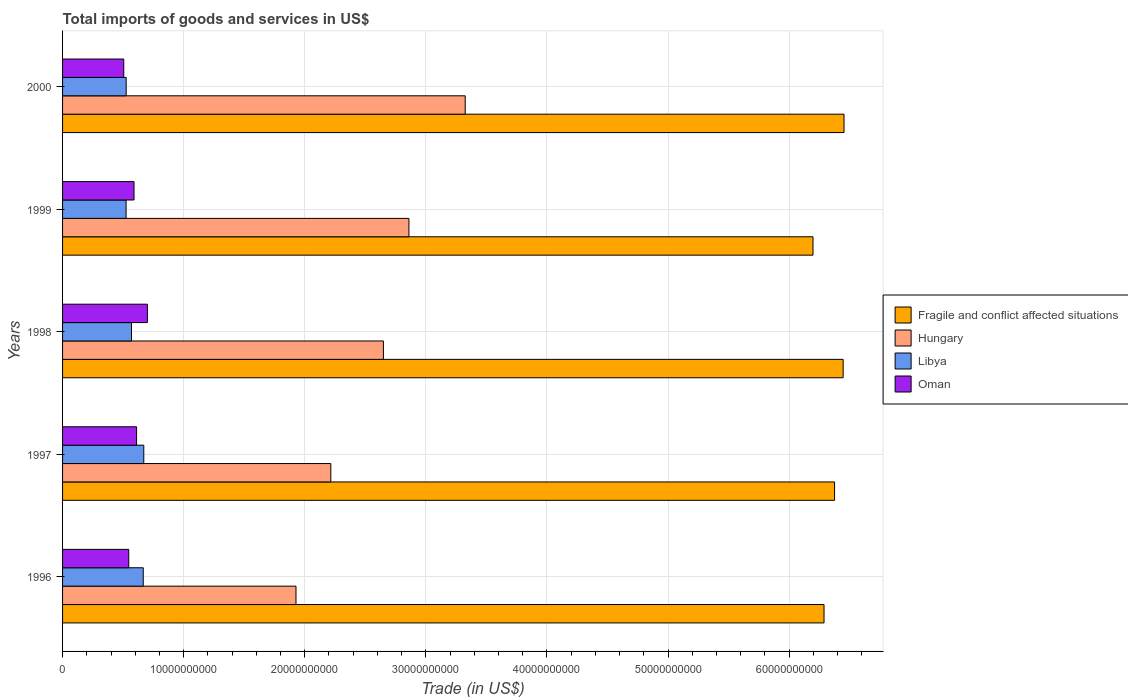Are the number of bars per tick equal to the number of legend labels?
Ensure brevity in your answer.  Yes. How many bars are there on the 4th tick from the top?
Ensure brevity in your answer.  4. How many bars are there on the 2nd tick from the bottom?
Your answer should be very brief. 4. What is the label of the 2nd group of bars from the top?
Make the answer very short. 1999. What is the total imports of goods and services in Hungary in 1997?
Your response must be concise. 2.22e+1. Across all years, what is the maximum total imports of goods and services in Libya?
Offer a terse response. 6.71e+09. Across all years, what is the minimum total imports of goods and services in Oman?
Give a very brief answer. 5.05e+09. In which year was the total imports of goods and services in Oman maximum?
Provide a succinct answer. 1998. What is the total total imports of goods and services in Fragile and conflict affected situations in the graph?
Make the answer very short. 3.18e+11. What is the difference between the total imports of goods and services in Hungary in 1996 and that in 2000?
Give a very brief answer. -1.40e+1. What is the difference between the total imports of goods and services in Libya in 2000 and the total imports of goods and services in Fragile and conflict affected situations in 1998?
Offer a very short reply. -5.92e+1. What is the average total imports of goods and services in Libya per year?
Ensure brevity in your answer.  5.91e+09. In the year 1996, what is the difference between the total imports of goods and services in Libya and total imports of goods and services in Fragile and conflict affected situations?
Provide a short and direct response. -5.62e+1. What is the ratio of the total imports of goods and services in Libya in 1996 to that in 1999?
Ensure brevity in your answer.  1.27. Is the total imports of goods and services in Libya in 1998 less than that in 1999?
Provide a succinct answer. No. Is the difference between the total imports of goods and services in Libya in 1996 and 2000 greater than the difference between the total imports of goods and services in Fragile and conflict affected situations in 1996 and 2000?
Make the answer very short. Yes. What is the difference between the highest and the second highest total imports of goods and services in Hungary?
Provide a succinct answer. 4.65e+09. What is the difference between the highest and the lowest total imports of goods and services in Hungary?
Your answer should be compact. 1.40e+1. Is the sum of the total imports of goods and services in Hungary in 1999 and 2000 greater than the maximum total imports of goods and services in Fragile and conflict affected situations across all years?
Your answer should be compact. No. Is it the case that in every year, the sum of the total imports of goods and services in Libya and total imports of goods and services in Oman is greater than the sum of total imports of goods and services in Fragile and conflict affected situations and total imports of goods and services in Hungary?
Give a very brief answer. No. What does the 3rd bar from the top in 1997 represents?
Offer a very short reply. Hungary. What does the 1st bar from the bottom in 1998 represents?
Make the answer very short. Fragile and conflict affected situations. How many bars are there?
Ensure brevity in your answer.  20. What is the difference between two consecutive major ticks on the X-axis?
Provide a short and direct response. 1.00e+1. Are the values on the major ticks of X-axis written in scientific E-notation?
Your response must be concise. No. Does the graph contain any zero values?
Your answer should be very brief. No. Does the graph contain grids?
Give a very brief answer. Yes. Where does the legend appear in the graph?
Offer a terse response. Center right. How many legend labels are there?
Keep it short and to the point. 4. What is the title of the graph?
Give a very brief answer. Total imports of goods and services in US$. What is the label or title of the X-axis?
Provide a short and direct response. Trade (in US$). What is the label or title of the Y-axis?
Make the answer very short. Years. What is the Trade (in US$) of Fragile and conflict affected situations in 1996?
Offer a very short reply. 6.29e+1. What is the Trade (in US$) in Hungary in 1996?
Ensure brevity in your answer.  1.93e+1. What is the Trade (in US$) of Libya in 1996?
Keep it short and to the point. 6.66e+09. What is the Trade (in US$) in Oman in 1996?
Your answer should be compact. 5.46e+09. What is the Trade (in US$) of Fragile and conflict affected situations in 1997?
Ensure brevity in your answer.  6.37e+1. What is the Trade (in US$) of Hungary in 1997?
Provide a short and direct response. 2.22e+1. What is the Trade (in US$) in Libya in 1997?
Your response must be concise. 6.71e+09. What is the Trade (in US$) in Oman in 1997?
Offer a terse response. 6.11e+09. What is the Trade (in US$) in Fragile and conflict affected situations in 1998?
Your answer should be very brief. 6.45e+1. What is the Trade (in US$) of Hungary in 1998?
Offer a very short reply. 2.65e+1. What is the Trade (in US$) in Libya in 1998?
Offer a terse response. 5.69e+09. What is the Trade (in US$) of Oman in 1998?
Your answer should be compact. 7.00e+09. What is the Trade (in US$) of Fragile and conflict affected situations in 1999?
Your answer should be compact. 6.20e+1. What is the Trade (in US$) in Hungary in 1999?
Make the answer very short. 2.86e+1. What is the Trade (in US$) in Libya in 1999?
Ensure brevity in your answer.  5.25e+09. What is the Trade (in US$) in Oman in 1999?
Offer a terse response. 5.90e+09. What is the Trade (in US$) of Fragile and conflict affected situations in 2000?
Provide a short and direct response. 6.45e+1. What is the Trade (in US$) of Hungary in 2000?
Your response must be concise. 3.32e+1. What is the Trade (in US$) of Libya in 2000?
Offer a very short reply. 5.25e+09. What is the Trade (in US$) in Oman in 2000?
Your response must be concise. 5.05e+09. Across all years, what is the maximum Trade (in US$) of Fragile and conflict affected situations?
Your answer should be compact. 6.45e+1. Across all years, what is the maximum Trade (in US$) in Hungary?
Make the answer very short. 3.32e+1. Across all years, what is the maximum Trade (in US$) in Libya?
Provide a short and direct response. 6.71e+09. Across all years, what is the maximum Trade (in US$) of Oman?
Your answer should be very brief. 7.00e+09. Across all years, what is the minimum Trade (in US$) of Fragile and conflict affected situations?
Provide a short and direct response. 6.20e+1. Across all years, what is the minimum Trade (in US$) of Hungary?
Ensure brevity in your answer.  1.93e+1. Across all years, what is the minimum Trade (in US$) of Libya?
Offer a terse response. 5.25e+09. Across all years, what is the minimum Trade (in US$) in Oman?
Give a very brief answer. 5.05e+09. What is the total Trade (in US$) in Fragile and conflict affected situations in the graph?
Your response must be concise. 3.18e+11. What is the total Trade (in US$) of Hungary in the graph?
Your answer should be compact. 1.30e+11. What is the total Trade (in US$) of Libya in the graph?
Offer a very short reply. 2.96e+1. What is the total Trade (in US$) in Oman in the graph?
Your response must be concise. 2.95e+1. What is the difference between the Trade (in US$) of Fragile and conflict affected situations in 1996 and that in 1997?
Your response must be concise. -8.70e+08. What is the difference between the Trade (in US$) in Hungary in 1996 and that in 1997?
Ensure brevity in your answer.  -2.88e+09. What is the difference between the Trade (in US$) in Libya in 1996 and that in 1997?
Offer a very short reply. -4.44e+07. What is the difference between the Trade (in US$) of Oman in 1996 and that in 1997?
Offer a very short reply. -6.48e+08. What is the difference between the Trade (in US$) of Fragile and conflict affected situations in 1996 and that in 1998?
Keep it short and to the point. -1.58e+09. What is the difference between the Trade (in US$) in Hungary in 1996 and that in 1998?
Offer a very short reply. -7.22e+09. What is the difference between the Trade (in US$) in Libya in 1996 and that in 1998?
Make the answer very short. 9.71e+08. What is the difference between the Trade (in US$) in Oman in 1996 and that in 1998?
Offer a terse response. -1.54e+09. What is the difference between the Trade (in US$) of Fragile and conflict affected situations in 1996 and that in 1999?
Ensure brevity in your answer.  9.10e+08. What is the difference between the Trade (in US$) of Hungary in 1996 and that in 1999?
Offer a terse response. -9.33e+09. What is the difference between the Trade (in US$) of Libya in 1996 and that in 1999?
Give a very brief answer. 1.42e+09. What is the difference between the Trade (in US$) of Oman in 1996 and that in 1999?
Give a very brief answer. -4.37e+08. What is the difference between the Trade (in US$) in Fragile and conflict affected situations in 1996 and that in 2000?
Ensure brevity in your answer.  -1.65e+09. What is the difference between the Trade (in US$) in Hungary in 1996 and that in 2000?
Your answer should be compact. -1.40e+1. What is the difference between the Trade (in US$) of Libya in 1996 and that in 2000?
Give a very brief answer. 1.41e+09. What is the difference between the Trade (in US$) in Oman in 1996 and that in 2000?
Your answer should be compact. 4.11e+08. What is the difference between the Trade (in US$) in Fragile and conflict affected situations in 1997 and that in 1998?
Your response must be concise. -7.10e+08. What is the difference between the Trade (in US$) in Hungary in 1997 and that in 1998?
Give a very brief answer. -4.34e+09. What is the difference between the Trade (in US$) in Libya in 1997 and that in 1998?
Keep it short and to the point. 1.02e+09. What is the difference between the Trade (in US$) of Oman in 1997 and that in 1998?
Your answer should be very brief. -8.92e+08. What is the difference between the Trade (in US$) of Fragile and conflict affected situations in 1997 and that in 1999?
Offer a terse response. 1.78e+09. What is the difference between the Trade (in US$) of Hungary in 1997 and that in 1999?
Make the answer very short. -6.45e+09. What is the difference between the Trade (in US$) of Libya in 1997 and that in 1999?
Provide a succinct answer. 1.46e+09. What is the difference between the Trade (in US$) in Oman in 1997 and that in 1999?
Provide a succinct answer. 2.11e+08. What is the difference between the Trade (in US$) in Fragile and conflict affected situations in 1997 and that in 2000?
Your answer should be very brief. -7.82e+08. What is the difference between the Trade (in US$) in Hungary in 1997 and that in 2000?
Give a very brief answer. -1.11e+1. What is the difference between the Trade (in US$) in Libya in 1997 and that in 2000?
Your answer should be very brief. 1.45e+09. What is the difference between the Trade (in US$) in Oman in 1997 and that in 2000?
Give a very brief answer. 1.06e+09. What is the difference between the Trade (in US$) of Fragile and conflict affected situations in 1998 and that in 1999?
Your answer should be compact. 2.49e+09. What is the difference between the Trade (in US$) of Hungary in 1998 and that in 1999?
Provide a succinct answer. -2.11e+09. What is the difference between the Trade (in US$) of Libya in 1998 and that in 1999?
Provide a succinct answer. 4.45e+08. What is the difference between the Trade (in US$) of Oman in 1998 and that in 1999?
Offer a very short reply. 1.10e+09. What is the difference between the Trade (in US$) in Fragile and conflict affected situations in 1998 and that in 2000?
Provide a short and direct response. -7.17e+07. What is the difference between the Trade (in US$) of Hungary in 1998 and that in 2000?
Offer a very short reply. -6.76e+09. What is the difference between the Trade (in US$) in Libya in 1998 and that in 2000?
Provide a short and direct response. 4.39e+08. What is the difference between the Trade (in US$) of Oman in 1998 and that in 2000?
Provide a short and direct response. 1.95e+09. What is the difference between the Trade (in US$) of Fragile and conflict affected situations in 1999 and that in 2000?
Your answer should be compact. -2.56e+09. What is the difference between the Trade (in US$) in Hungary in 1999 and that in 2000?
Ensure brevity in your answer.  -4.65e+09. What is the difference between the Trade (in US$) of Libya in 1999 and that in 2000?
Give a very brief answer. -6.06e+06. What is the difference between the Trade (in US$) of Oman in 1999 and that in 2000?
Keep it short and to the point. 8.48e+08. What is the difference between the Trade (in US$) in Fragile and conflict affected situations in 1996 and the Trade (in US$) in Hungary in 1997?
Provide a succinct answer. 4.07e+1. What is the difference between the Trade (in US$) in Fragile and conflict affected situations in 1996 and the Trade (in US$) in Libya in 1997?
Make the answer very short. 5.62e+1. What is the difference between the Trade (in US$) of Fragile and conflict affected situations in 1996 and the Trade (in US$) of Oman in 1997?
Your answer should be compact. 5.68e+1. What is the difference between the Trade (in US$) of Hungary in 1996 and the Trade (in US$) of Libya in 1997?
Your response must be concise. 1.26e+1. What is the difference between the Trade (in US$) in Hungary in 1996 and the Trade (in US$) in Oman in 1997?
Make the answer very short. 1.32e+1. What is the difference between the Trade (in US$) of Libya in 1996 and the Trade (in US$) of Oman in 1997?
Provide a succinct answer. 5.50e+08. What is the difference between the Trade (in US$) in Fragile and conflict affected situations in 1996 and the Trade (in US$) in Hungary in 1998?
Your answer should be very brief. 3.64e+1. What is the difference between the Trade (in US$) of Fragile and conflict affected situations in 1996 and the Trade (in US$) of Libya in 1998?
Provide a short and direct response. 5.72e+1. What is the difference between the Trade (in US$) of Fragile and conflict affected situations in 1996 and the Trade (in US$) of Oman in 1998?
Provide a short and direct response. 5.59e+1. What is the difference between the Trade (in US$) in Hungary in 1996 and the Trade (in US$) in Libya in 1998?
Ensure brevity in your answer.  1.36e+1. What is the difference between the Trade (in US$) in Hungary in 1996 and the Trade (in US$) in Oman in 1998?
Provide a succinct answer. 1.23e+1. What is the difference between the Trade (in US$) in Libya in 1996 and the Trade (in US$) in Oman in 1998?
Give a very brief answer. -3.42e+08. What is the difference between the Trade (in US$) in Fragile and conflict affected situations in 1996 and the Trade (in US$) in Hungary in 1999?
Give a very brief answer. 3.43e+1. What is the difference between the Trade (in US$) of Fragile and conflict affected situations in 1996 and the Trade (in US$) of Libya in 1999?
Your answer should be compact. 5.76e+1. What is the difference between the Trade (in US$) of Fragile and conflict affected situations in 1996 and the Trade (in US$) of Oman in 1999?
Provide a short and direct response. 5.70e+1. What is the difference between the Trade (in US$) in Hungary in 1996 and the Trade (in US$) in Libya in 1999?
Ensure brevity in your answer.  1.40e+1. What is the difference between the Trade (in US$) in Hungary in 1996 and the Trade (in US$) in Oman in 1999?
Provide a short and direct response. 1.34e+1. What is the difference between the Trade (in US$) in Libya in 1996 and the Trade (in US$) in Oman in 1999?
Ensure brevity in your answer.  7.61e+08. What is the difference between the Trade (in US$) of Fragile and conflict affected situations in 1996 and the Trade (in US$) of Hungary in 2000?
Your response must be concise. 2.96e+1. What is the difference between the Trade (in US$) in Fragile and conflict affected situations in 1996 and the Trade (in US$) in Libya in 2000?
Provide a succinct answer. 5.76e+1. What is the difference between the Trade (in US$) in Fragile and conflict affected situations in 1996 and the Trade (in US$) in Oman in 2000?
Offer a terse response. 5.78e+1. What is the difference between the Trade (in US$) of Hungary in 1996 and the Trade (in US$) of Libya in 2000?
Your answer should be compact. 1.40e+1. What is the difference between the Trade (in US$) in Hungary in 1996 and the Trade (in US$) in Oman in 2000?
Ensure brevity in your answer.  1.42e+1. What is the difference between the Trade (in US$) in Libya in 1996 and the Trade (in US$) in Oman in 2000?
Offer a very short reply. 1.61e+09. What is the difference between the Trade (in US$) of Fragile and conflict affected situations in 1997 and the Trade (in US$) of Hungary in 1998?
Your response must be concise. 3.73e+1. What is the difference between the Trade (in US$) of Fragile and conflict affected situations in 1997 and the Trade (in US$) of Libya in 1998?
Your response must be concise. 5.81e+1. What is the difference between the Trade (in US$) in Fragile and conflict affected situations in 1997 and the Trade (in US$) in Oman in 1998?
Make the answer very short. 5.67e+1. What is the difference between the Trade (in US$) of Hungary in 1997 and the Trade (in US$) of Libya in 1998?
Provide a short and direct response. 1.65e+1. What is the difference between the Trade (in US$) in Hungary in 1997 and the Trade (in US$) in Oman in 1998?
Give a very brief answer. 1.51e+1. What is the difference between the Trade (in US$) in Libya in 1997 and the Trade (in US$) in Oman in 1998?
Your answer should be compact. -2.97e+08. What is the difference between the Trade (in US$) in Fragile and conflict affected situations in 1997 and the Trade (in US$) in Hungary in 1999?
Keep it short and to the point. 3.51e+1. What is the difference between the Trade (in US$) in Fragile and conflict affected situations in 1997 and the Trade (in US$) in Libya in 1999?
Your answer should be very brief. 5.85e+1. What is the difference between the Trade (in US$) of Fragile and conflict affected situations in 1997 and the Trade (in US$) of Oman in 1999?
Provide a short and direct response. 5.78e+1. What is the difference between the Trade (in US$) of Hungary in 1997 and the Trade (in US$) of Libya in 1999?
Your answer should be compact. 1.69e+1. What is the difference between the Trade (in US$) of Hungary in 1997 and the Trade (in US$) of Oman in 1999?
Provide a short and direct response. 1.62e+1. What is the difference between the Trade (in US$) of Libya in 1997 and the Trade (in US$) of Oman in 1999?
Your answer should be very brief. 8.05e+08. What is the difference between the Trade (in US$) in Fragile and conflict affected situations in 1997 and the Trade (in US$) in Hungary in 2000?
Ensure brevity in your answer.  3.05e+1. What is the difference between the Trade (in US$) in Fragile and conflict affected situations in 1997 and the Trade (in US$) in Libya in 2000?
Your answer should be compact. 5.85e+1. What is the difference between the Trade (in US$) in Fragile and conflict affected situations in 1997 and the Trade (in US$) in Oman in 2000?
Make the answer very short. 5.87e+1. What is the difference between the Trade (in US$) in Hungary in 1997 and the Trade (in US$) in Libya in 2000?
Your answer should be very brief. 1.69e+1. What is the difference between the Trade (in US$) in Hungary in 1997 and the Trade (in US$) in Oman in 2000?
Offer a terse response. 1.71e+1. What is the difference between the Trade (in US$) of Libya in 1997 and the Trade (in US$) of Oman in 2000?
Your answer should be very brief. 1.65e+09. What is the difference between the Trade (in US$) in Fragile and conflict affected situations in 1998 and the Trade (in US$) in Hungary in 1999?
Offer a very short reply. 3.59e+1. What is the difference between the Trade (in US$) of Fragile and conflict affected situations in 1998 and the Trade (in US$) of Libya in 1999?
Your answer should be very brief. 5.92e+1. What is the difference between the Trade (in US$) of Fragile and conflict affected situations in 1998 and the Trade (in US$) of Oman in 1999?
Provide a short and direct response. 5.86e+1. What is the difference between the Trade (in US$) of Hungary in 1998 and the Trade (in US$) of Libya in 1999?
Provide a succinct answer. 2.12e+1. What is the difference between the Trade (in US$) of Hungary in 1998 and the Trade (in US$) of Oman in 1999?
Give a very brief answer. 2.06e+1. What is the difference between the Trade (in US$) of Libya in 1998 and the Trade (in US$) of Oman in 1999?
Ensure brevity in your answer.  -2.10e+08. What is the difference between the Trade (in US$) of Fragile and conflict affected situations in 1998 and the Trade (in US$) of Hungary in 2000?
Offer a terse response. 3.12e+1. What is the difference between the Trade (in US$) of Fragile and conflict affected situations in 1998 and the Trade (in US$) of Libya in 2000?
Keep it short and to the point. 5.92e+1. What is the difference between the Trade (in US$) in Fragile and conflict affected situations in 1998 and the Trade (in US$) in Oman in 2000?
Offer a very short reply. 5.94e+1. What is the difference between the Trade (in US$) in Hungary in 1998 and the Trade (in US$) in Libya in 2000?
Provide a succinct answer. 2.12e+1. What is the difference between the Trade (in US$) in Hungary in 1998 and the Trade (in US$) in Oman in 2000?
Ensure brevity in your answer.  2.14e+1. What is the difference between the Trade (in US$) of Libya in 1998 and the Trade (in US$) of Oman in 2000?
Keep it short and to the point. 6.37e+08. What is the difference between the Trade (in US$) of Fragile and conflict affected situations in 1999 and the Trade (in US$) of Hungary in 2000?
Provide a short and direct response. 2.87e+1. What is the difference between the Trade (in US$) of Fragile and conflict affected situations in 1999 and the Trade (in US$) of Libya in 2000?
Make the answer very short. 5.67e+1. What is the difference between the Trade (in US$) of Fragile and conflict affected situations in 1999 and the Trade (in US$) of Oman in 2000?
Ensure brevity in your answer.  5.69e+1. What is the difference between the Trade (in US$) in Hungary in 1999 and the Trade (in US$) in Libya in 2000?
Offer a very short reply. 2.33e+1. What is the difference between the Trade (in US$) in Hungary in 1999 and the Trade (in US$) in Oman in 2000?
Offer a terse response. 2.35e+1. What is the difference between the Trade (in US$) of Libya in 1999 and the Trade (in US$) of Oman in 2000?
Your answer should be compact. 1.92e+08. What is the average Trade (in US$) of Fragile and conflict affected situations per year?
Provide a short and direct response. 6.35e+1. What is the average Trade (in US$) in Hungary per year?
Ensure brevity in your answer.  2.60e+1. What is the average Trade (in US$) of Libya per year?
Your answer should be compact. 5.91e+09. What is the average Trade (in US$) of Oman per year?
Your response must be concise. 5.91e+09. In the year 1996, what is the difference between the Trade (in US$) in Fragile and conflict affected situations and Trade (in US$) in Hungary?
Make the answer very short. 4.36e+1. In the year 1996, what is the difference between the Trade (in US$) in Fragile and conflict affected situations and Trade (in US$) in Libya?
Keep it short and to the point. 5.62e+1. In the year 1996, what is the difference between the Trade (in US$) in Fragile and conflict affected situations and Trade (in US$) in Oman?
Ensure brevity in your answer.  5.74e+1. In the year 1996, what is the difference between the Trade (in US$) in Hungary and Trade (in US$) in Libya?
Your answer should be compact. 1.26e+1. In the year 1996, what is the difference between the Trade (in US$) of Hungary and Trade (in US$) of Oman?
Your response must be concise. 1.38e+1. In the year 1996, what is the difference between the Trade (in US$) in Libya and Trade (in US$) in Oman?
Give a very brief answer. 1.20e+09. In the year 1997, what is the difference between the Trade (in US$) in Fragile and conflict affected situations and Trade (in US$) in Hungary?
Your answer should be compact. 4.16e+1. In the year 1997, what is the difference between the Trade (in US$) of Fragile and conflict affected situations and Trade (in US$) of Libya?
Provide a succinct answer. 5.70e+1. In the year 1997, what is the difference between the Trade (in US$) of Fragile and conflict affected situations and Trade (in US$) of Oman?
Your answer should be compact. 5.76e+1. In the year 1997, what is the difference between the Trade (in US$) in Hungary and Trade (in US$) in Libya?
Offer a terse response. 1.54e+1. In the year 1997, what is the difference between the Trade (in US$) in Hungary and Trade (in US$) in Oman?
Your response must be concise. 1.60e+1. In the year 1997, what is the difference between the Trade (in US$) of Libya and Trade (in US$) of Oman?
Offer a very short reply. 5.95e+08. In the year 1998, what is the difference between the Trade (in US$) of Fragile and conflict affected situations and Trade (in US$) of Hungary?
Your answer should be very brief. 3.80e+1. In the year 1998, what is the difference between the Trade (in US$) in Fragile and conflict affected situations and Trade (in US$) in Libya?
Make the answer very short. 5.88e+1. In the year 1998, what is the difference between the Trade (in US$) of Fragile and conflict affected situations and Trade (in US$) of Oman?
Offer a very short reply. 5.75e+1. In the year 1998, what is the difference between the Trade (in US$) of Hungary and Trade (in US$) of Libya?
Offer a terse response. 2.08e+1. In the year 1998, what is the difference between the Trade (in US$) in Hungary and Trade (in US$) in Oman?
Provide a short and direct response. 1.95e+1. In the year 1998, what is the difference between the Trade (in US$) of Libya and Trade (in US$) of Oman?
Ensure brevity in your answer.  -1.31e+09. In the year 1999, what is the difference between the Trade (in US$) in Fragile and conflict affected situations and Trade (in US$) in Hungary?
Keep it short and to the point. 3.34e+1. In the year 1999, what is the difference between the Trade (in US$) of Fragile and conflict affected situations and Trade (in US$) of Libya?
Offer a terse response. 5.67e+1. In the year 1999, what is the difference between the Trade (in US$) in Fragile and conflict affected situations and Trade (in US$) in Oman?
Your answer should be compact. 5.61e+1. In the year 1999, what is the difference between the Trade (in US$) of Hungary and Trade (in US$) of Libya?
Provide a succinct answer. 2.34e+1. In the year 1999, what is the difference between the Trade (in US$) of Hungary and Trade (in US$) of Oman?
Ensure brevity in your answer.  2.27e+1. In the year 1999, what is the difference between the Trade (in US$) of Libya and Trade (in US$) of Oman?
Your answer should be very brief. -6.55e+08. In the year 2000, what is the difference between the Trade (in US$) of Fragile and conflict affected situations and Trade (in US$) of Hungary?
Give a very brief answer. 3.13e+1. In the year 2000, what is the difference between the Trade (in US$) of Fragile and conflict affected situations and Trade (in US$) of Libya?
Your response must be concise. 5.93e+1. In the year 2000, what is the difference between the Trade (in US$) in Fragile and conflict affected situations and Trade (in US$) in Oman?
Offer a very short reply. 5.95e+1. In the year 2000, what is the difference between the Trade (in US$) of Hungary and Trade (in US$) of Libya?
Give a very brief answer. 2.80e+1. In the year 2000, what is the difference between the Trade (in US$) of Hungary and Trade (in US$) of Oman?
Provide a short and direct response. 2.82e+1. In the year 2000, what is the difference between the Trade (in US$) of Libya and Trade (in US$) of Oman?
Provide a short and direct response. 1.99e+08. What is the ratio of the Trade (in US$) in Fragile and conflict affected situations in 1996 to that in 1997?
Your response must be concise. 0.99. What is the ratio of the Trade (in US$) of Hungary in 1996 to that in 1997?
Your answer should be compact. 0.87. What is the ratio of the Trade (in US$) of Oman in 1996 to that in 1997?
Ensure brevity in your answer.  0.89. What is the ratio of the Trade (in US$) of Fragile and conflict affected situations in 1996 to that in 1998?
Your answer should be compact. 0.98. What is the ratio of the Trade (in US$) of Hungary in 1996 to that in 1998?
Offer a terse response. 0.73. What is the ratio of the Trade (in US$) in Libya in 1996 to that in 1998?
Give a very brief answer. 1.17. What is the ratio of the Trade (in US$) of Oman in 1996 to that in 1998?
Provide a short and direct response. 0.78. What is the ratio of the Trade (in US$) in Fragile and conflict affected situations in 1996 to that in 1999?
Keep it short and to the point. 1.01. What is the ratio of the Trade (in US$) in Hungary in 1996 to that in 1999?
Ensure brevity in your answer.  0.67. What is the ratio of the Trade (in US$) of Libya in 1996 to that in 1999?
Your answer should be very brief. 1.27. What is the ratio of the Trade (in US$) in Oman in 1996 to that in 1999?
Give a very brief answer. 0.93. What is the ratio of the Trade (in US$) of Fragile and conflict affected situations in 1996 to that in 2000?
Give a very brief answer. 0.97. What is the ratio of the Trade (in US$) of Hungary in 1996 to that in 2000?
Make the answer very short. 0.58. What is the ratio of the Trade (in US$) of Libya in 1996 to that in 2000?
Give a very brief answer. 1.27. What is the ratio of the Trade (in US$) of Oman in 1996 to that in 2000?
Ensure brevity in your answer.  1.08. What is the ratio of the Trade (in US$) in Hungary in 1997 to that in 1998?
Make the answer very short. 0.84. What is the ratio of the Trade (in US$) in Libya in 1997 to that in 1998?
Give a very brief answer. 1.18. What is the ratio of the Trade (in US$) in Oman in 1997 to that in 1998?
Provide a succinct answer. 0.87. What is the ratio of the Trade (in US$) of Fragile and conflict affected situations in 1997 to that in 1999?
Give a very brief answer. 1.03. What is the ratio of the Trade (in US$) of Hungary in 1997 to that in 1999?
Give a very brief answer. 0.77. What is the ratio of the Trade (in US$) in Libya in 1997 to that in 1999?
Provide a succinct answer. 1.28. What is the ratio of the Trade (in US$) in Oman in 1997 to that in 1999?
Your answer should be very brief. 1.04. What is the ratio of the Trade (in US$) in Fragile and conflict affected situations in 1997 to that in 2000?
Keep it short and to the point. 0.99. What is the ratio of the Trade (in US$) in Hungary in 1997 to that in 2000?
Your answer should be compact. 0.67. What is the ratio of the Trade (in US$) of Libya in 1997 to that in 2000?
Provide a succinct answer. 1.28. What is the ratio of the Trade (in US$) in Oman in 1997 to that in 2000?
Keep it short and to the point. 1.21. What is the ratio of the Trade (in US$) in Fragile and conflict affected situations in 1998 to that in 1999?
Offer a very short reply. 1.04. What is the ratio of the Trade (in US$) of Hungary in 1998 to that in 1999?
Offer a very short reply. 0.93. What is the ratio of the Trade (in US$) in Libya in 1998 to that in 1999?
Keep it short and to the point. 1.08. What is the ratio of the Trade (in US$) in Oman in 1998 to that in 1999?
Your response must be concise. 1.19. What is the ratio of the Trade (in US$) in Fragile and conflict affected situations in 1998 to that in 2000?
Give a very brief answer. 1. What is the ratio of the Trade (in US$) in Hungary in 1998 to that in 2000?
Provide a succinct answer. 0.8. What is the ratio of the Trade (in US$) in Libya in 1998 to that in 2000?
Provide a succinct answer. 1.08. What is the ratio of the Trade (in US$) in Oman in 1998 to that in 2000?
Give a very brief answer. 1.39. What is the ratio of the Trade (in US$) in Fragile and conflict affected situations in 1999 to that in 2000?
Your answer should be very brief. 0.96. What is the ratio of the Trade (in US$) in Hungary in 1999 to that in 2000?
Keep it short and to the point. 0.86. What is the ratio of the Trade (in US$) in Oman in 1999 to that in 2000?
Your response must be concise. 1.17. What is the difference between the highest and the second highest Trade (in US$) in Fragile and conflict affected situations?
Your answer should be very brief. 7.17e+07. What is the difference between the highest and the second highest Trade (in US$) of Hungary?
Offer a terse response. 4.65e+09. What is the difference between the highest and the second highest Trade (in US$) of Libya?
Your answer should be compact. 4.44e+07. What is the difference between the highest and the second highest Trade (in US$) in Oman?
Provide a succinct answer. 8.92e+08. What is the difference between the highest and the lowest Trade (in US$) of Fragile and conflict affected situations?
Ensure brevity in your answer.  2.56e+09. What is the difference between the highest and the lowest Trade (in US$) in Hungary?
Your answer should be very brief. 1.40e+1. What is the difference between the highest and the lowest Trade (in US$) of Libya?
Offer a very short reply. 1.46e+09. What is the difference between the highest and the lowest Trade (in US$) in Oman?
Make the answer very short. 1.95e+09. 